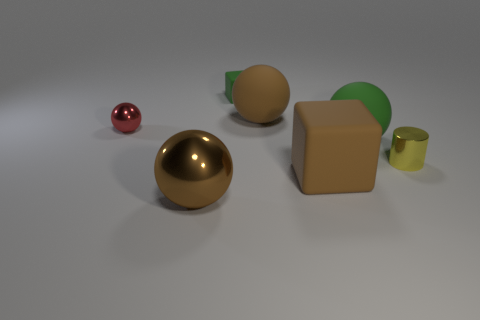What material is the ball that is the same color as the small rubber cube?
Your response must be concise. Rubber. Are there any green matte objects of the same shape as the big brown metallic thing?
Provide a short and direct response. Yes. Is the brown ball behind the tiny red metallic ball made of the same material as the block that is behind the small yellow object?
Your answer should be very brief. Yes. There is a rubber ball that is to the right of the big brown ball to the right of the large brown sphere that is in front of the large brown rubber cube; how big is it?
Provide a succinct answer. Large. There is a block that is the same size as the green matte sphere; what is its material?
Offer a terse response. Rubber. Are there any gray objects that have the same size as the red thing?
Ensure brevity in your answer.  No. Do the red shiny thing and the tiny yellow thing have the same shape?
Keep it short and to the point. No. Are there any brown things that are in front of the green rubber object that is in front of the large brown object behind the metallic cylinder?
Provide a succinct answer. Yes. How many other things are there of the same color as the small metallic cylinder?
Offer a very short reply. 0. Do the brown matte thing that is in front of the tiny yellow thing and the brown thing behind the yellow shiny object have the same size?
Give a very brief answer. Yes. 